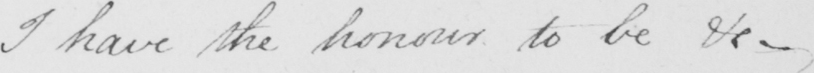Transcribe the text shown in this historical manuscript line. I have the honour to be &c  _ 